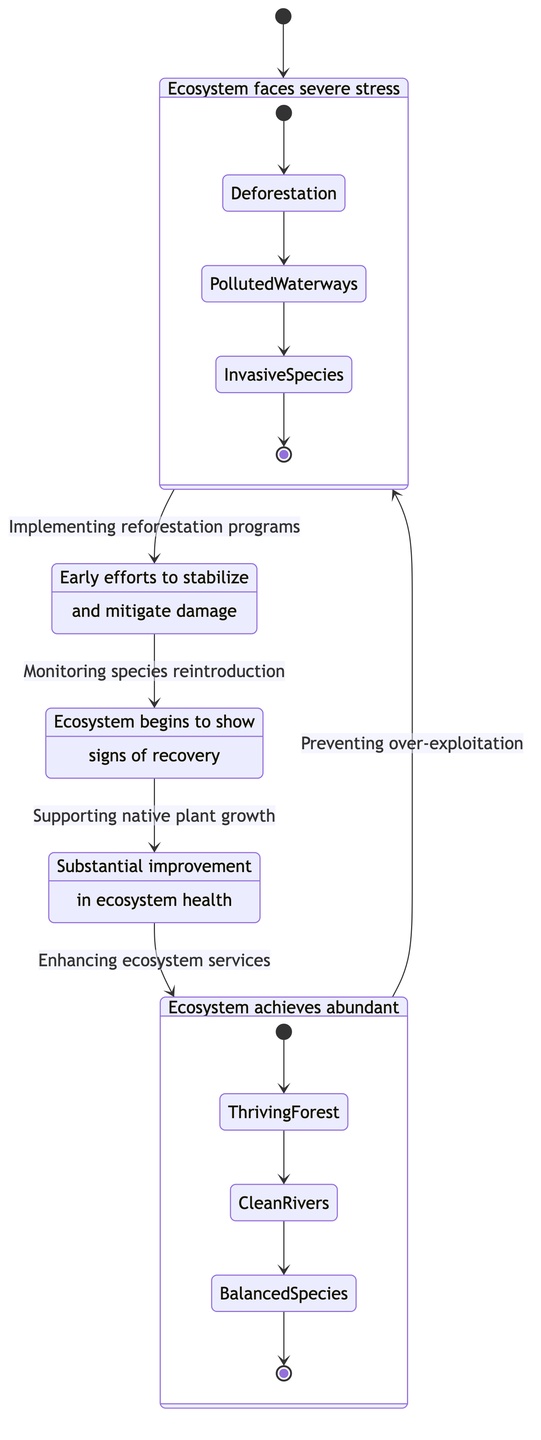What is the starting state in the diagram? The diagram begins with the initial state labeled "Degradation," indicating a severe stress condition on the ecosystem. This is the state connected to the starting point of the diagram.
Answer: Degradation How many states are represented in the diagram? By counting the labeled states "Degradation," "Initiation," "Stabilization," "Recovery," and "Flourishment," we determine there are five distinct states illustrated in the diagram.
Answer: 5 What action leads from "Recovery" to "Flourishment"? The transition from "Recovery" to "Flourishment" is achieved through the action "Enhancing ecosystem services," which signifies an important step towards full restoration.
Answer: Enhancing ecosystem services Which state demonstrates the most abundant biodiversity? The "Flourishment" state represents the ultimate condition of abundant biodiversity and ecological balance, showcasing a flourishing ecosystem.
Answer: Flourishment What condition does the "Degradation" state describe about the ecosystem? The "Degradation" state indicates that the ecosystem faces severe stress and a decline in biodiversity, emphasizing the critical challenges it encounters.
Answer: Severe stress and decline in biodiversity What transition occurs directly after "Initiation"? After "Initiation," the next transition occurs to the "Stabilization" state, signifying a progression towards ecosystem recovery following initial restorative actions.
Answer: Stabilization What is a major action taken to move from "Stabilization" to "Recovery"? The critical action facilitating the transition from "Stabilization" to "Recovery" is "Supporting native plant growth," which aids in restoring ecosystem health.
Answer: Supporting native plant growth What happens if the ecosystem reaches the "Flourishment" state? If the ecosystem reaches the "Flourishment" state, it signifies the achievement of abundant biodiversity and ecological balance, marking a successful restoration.
Answer: Abundant biodiversity and ecological balance Which state involves efforts like "Pollution control programs"? The "Initiation" state includes efforts such as "Pollution control programs," which are essential actions taken to begin the recovery process.
Answer: Initiation 